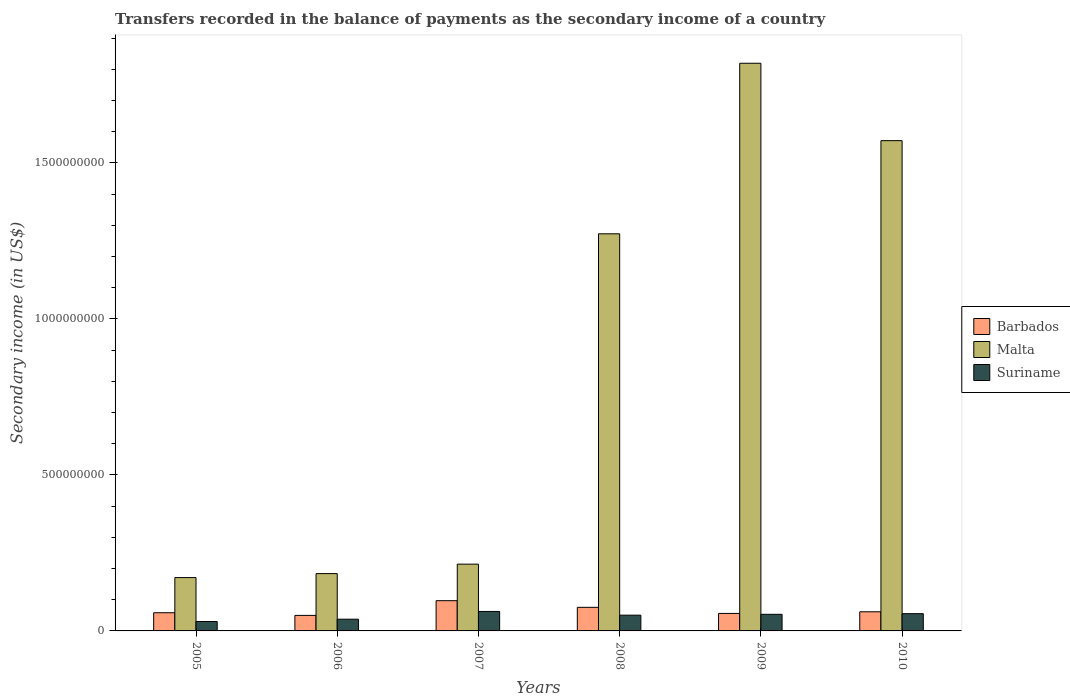How many different coloured bars are there?
Give a very brief answer. 3. How many groups of bars are there?
Your response must be concise. 6. Are the number of bars per tick equal to the number of legend labels?
Make the answer very short. Yes. How many bars are there on the 5th tick from the right?
Your answer should be compact. 3. What is the label of the 2nd group of bars from the left?
Keep it short and to the point. 2006. In how many cases, is the number of bars for a given year not equal to the number of legend labels?
Provide a succinct answer. 0. What is the secondary income of in Barbados in 2005?
Your response must be concise. 5.83e+07. Across all years, what is the maximum secondary income of in Suriname?
Provide a succinct answer. 6.24e+07. Across all years, what is the minimum secondary income of in Malta?
Your answer should be compact. 1.71e+08. What is the total secondary income of in Suriname in the graph?
Your answer should be very brief. 2.89e+08. What is the difference between the secondary income of in Malta in 2006 and that in 2008?
Give a very brief answer. -1.09e+09. What is the difference between the secondary income of in Barbados in 2008 and the secondary income of in Malta in 2009?
Your answer should be compact. -1.74e+09. What is the average secondary income of in Malta per year?
Your response must be concise. 8.72e+08. In the year 2010, what is the difference between the secondary income of in Suriname and secondary income of in Malta?
Ensure brevity in your answer.  -1.52e+09. What is the ratio of the secondary income of in Barbados in 2008 to that in 2010?
Make the answer very short. 1.23. Is the secondary income of in Barbados in 2005 less than that in 2007?
Give a very brief answer. Yes. Is the difference between the secondary income of in Suriname in 2007 and 2008 greater than the difference between the secondary income of in Malta in 2007 and 2008?
Your answer should be compact. Yes. What is the difference between the highest and the second highest secondary income of in Barbados?
Offer a very short reply. 2.13e+07. What is the difference between the highest and the lowest secondary income of in Malta?
Offer a terse response. 1.65e+09. What does the 3rd bar from the left in 2007 represents?
Your response must be concise. Suriname. What does the 2nd bar from the right in 2009 represents?
Make the answer very short. Malta. Is it the case that in every year, the sum of the secondary income of in Barbados and secondary income of in Suriname is greater than the secondary income of in Malta?
Keep it short and to the point. No. How many bars are there?
Your response must be concise. 18. How many years are there in the graph?
Your answer should be compact. 6. What is the difference between two consecutive major ticks on the Y-axis?
Provide a short and direct response. 5.00e+08. How are the legend labels stacked?
Offer a very short reply. Vertical. What is the title of the graph?
Your response must be concise. Transfers recorded in the balance of payments as the secondary income of a country. What is the label or title of the Y-axis?
Offer a very short reply. Secondary income (in US$). What is the Secondary income (in US$) in Barbados in 2005?
Offer a very short reply. 5.83e+07. What is the Secondary income (in US$) of Malta in 2005?
Your response must be concise. 1.71e+08. What is the Secondary income (in US$) in Suriname in 2005?
Keep it short and to the point. 3.02e+07. What is the Secondary income (in US$) in Barbados in 2006?
Make the answer very short. 4.97e+07. What is the Secondary income (in US$) in Malta in 2006?
Offer a terse response. 1.84e+08. What is the Secondary income (in US$) in Suriname in 2006?
Your answer should be compact. 3.76e+07. What is the Secondary income (in US$) in Barbados in 2007?
Keep it short and to the point. 9.69e+07. What is the Secondary income (in US$) in Malta in 2007?
Offer a terse response. 2.14e+08. What is the Secondary income (in US$) of Suriname in 2007?
Provide a succinct answer. 6.24e+07. What is the Secondary income (in US$) of Barbados in 2008?
Offer a terse response. 7.56e+07. What is the Secondary income (in US$) of Malta in 2008?
Provide a succinct answer. 1.27e+09. What is the Secondary income (in US$) in Suriname in 2008?
Ensure brevity in your answer.  5.05e+07. What is the Secondary income (in US$) of Barbados in 2009?
Ensure brevity in your answer.  5.61e+07. What is the Secondary income (in US$) in Malta in 2009?
Keep it short and to the point. 1.82e+09. What is the Secondary income (in US$) in Suriname in 2009?
Give a very brief answer. 5.32e+07. What is the Secondary income (in US$) in Barbados in 2010?
Offer a very short reply. 6.13e+07. What is the Secondary income (in US$) of Malta in 2010?
Your answer should be compact. 1.57e+09. What is the Secondary income (in US$) of Suriname in 2010?
Keep it short and to the point. 5.53e+07. Across all years, what is the maximum Secondary income (in US$) of Barbados?
Your response must be concise. 9.69e+07. Across all years, what is the maximum Secondary income (in US$) of Malta?
Make the answer very short. 1.82e+09. Across all years, what is the maximum Secondary income (in US$) of Suriname?
Make the answer very short. 6.24e+07. Across all years, what is the minimum Secondary income (in US$) in Barbados?
Provide a short and direct response. 4.97e+07. Across all years, what is the minimum Secondary income (in US$) in Malta?
Offer a very short reply. 1.71e+08. Across all years, what is the minimum Secondary income (in US$) of Suriname?
Your response must be concise. 3.02e+07. What is the total Secondary income (in US$) in Barbados in the graph?
Give a very brief answer. 3.98e+08. What is the total Secondary income (in US$) in Malta in the graph?
Keep it short and to the point. 5.23e+09. What is the total Secondary income (in US$) in Suriname in the graph?
Ensure brevity in your answer.  2.89e+08. What is the difference between the Secondary income (in US$) of Barbados in 2005 and that in 2006?
Provide a short and direct response. 8.51e+06. What is the difference between the Secondary income (in US$) of Malta in 2005 and that in 2006?
Keep it short and to the point. -1.27e+07. What is the difference between the Secondary income (in US$) of Suriname in 2005 and that in 2006?
Ensure brevity in your answer.  -7.40e+06. What is the difference between the Secondary income (in US$) in Barbados in 2005 and that in 2007?
Ensure brevity in your answer.  -3.86e+07. What is the difference between the Secondary income (in US$) in Malta in 2005 and that in 2007?
Your response must be concise. -4.30e+07. What is the difference between the Secondary income (in US$) in Suriname in 2005 and that in 2007?
Your answer should be compact. -3.22e+07. What is the difference between the Secondary income (in US$) in Barbados in 2005 and that in 2008?
Keep it short and to the point. -1.73e+07. What is the difference between the Secondary income (in US$) in Malta in 2005 and that in 2008?
Make the answer very short. -1.10e+09. What is the difference between the Secondary income (in US$) of Suriname in 2005 and that in 2008?
Your response must be concise. -2.03e+07. What is the difference between the Secondary income (in US$) in Barbados in 2005 and that in 2009?
Provide a succinct answer. 2.20e+06. What is the difference between the Secondary income (in US$) in Malta in 2005 and that in 2009?
Give a very brief answer. -1.65e+09. What is the difference between the Secondary income (in US$) of Suriname in 2005 and that in 2009?
Offer a terse response. -2.30e+07. What is the difference between the Secondary income (in US$) in Barbados in 2005 and that in 2010?
Keep it short and to the point. -3.06e+06. What is the difference between the Secondary income (in US$) in Malta in 2005 and that in 2010?
Make the answer very short. -1.40e+09. What is the difference between the Secondary income (in US$) of Suriname in 2005 and that in 2010?
Keep it short and to the point. -2.51e+07. What is the difference between the Secondary income (in US$) in Barbados in 2006 and that in 2007?
Give a very brief answer. -4.71e+07. What is the difference between the Secondary income (in US$) in Malta in 2006 and that in 2007?
Provide a succinct answer. -3.03e+07. What is the difference between the Secondary income (in US$) in Suriname in 2006 and that in 2007?
Offer a terse response. -2.48e+07. What is the difference between the Secondary income (in US$) in Barbados in 2006 and that in 2008?
Make the answer very short. -2.58e+07. What is the difference between the Secondary income (in US$) of Malta in 2006 and that in 2008?
Your answer should be very brief. -1.09e+09. What is the difference between the Secondary income (in US$) of Suriname in 2006 and that in 2008?
Your answer should be very brief. -1.29e+07. What is the difference between the Secondary income (in US$) in Barbados in 2006 and that in 2009?
Make the answer very short. -6.32e+06. What is the difference between the Secondary income (in US$) in Malta in 2006 and that in 2009?
Your response must be concise. -1.64e+09. What is the difference between the Secondary income (in US$) of Suriname in 2006 and that in 2009?
Provide a succinct answer. -1.56e+07. What is the difference between the Secondary income (in US$) of Barbados in 2006 and that in 2010?
Your answer should be very brief. -1.16e+07. What is the difference between the Secondary income (in US$) of Malta in 2006 and that in 2010?
Provide a short and direct response. -1.39e+09. What is the difference between the Secondary income (in US$) in Suriname in 2006 and that in 2010?
Offer a terse response. -1.77e+07. What is the difference between the Secondary income (in US$) of Barbados in 2007 and that in 2008?
Your response must be concise. 2.13e+07. What is the difference between the Secondary income (in US$) of Malta in 2007 and that in 2008?
Offer a terse response. -1.06e+09. What is the difference between the Secondary income (in US$) of Suriname in 2007 and that in 2008?
Ensure brevity in your answer.  1.19e+07. What is the difference between the Secondary income (in US$) in Barbados in 2007 and that in 2009?
Offer a very short reply. 4.08e+07. What is the difference between the Secondary income (in US$) in Malta in 2007 and that in 2009?
Give a very brief answer. -1.61e+09. What is the difference between the Secondary income (in US$) in Suriname in 2007 and that in 2009?
Give a very brief answer. 9.20e+06. What is the difference between the Secondary income (in US$) of Barbados in 2007 and that in 2010?
Ensure brevity in your answer.  3.56e+07. What is the difference between the Secondary income (in US$) in Malta in 2007 and that in 2010?
Your answer should be very brief. -1.36e+09. What is the difference between the Secondary income (in US$) in Suriname in 2007 and that in 2010?
Offer a very short reply. 7.10e+06. What is the difference between the Secondary income (in US$) in Barbados in 2008 and that in 2009?
Offer a very short reply. 1.95e+07. What is the difference between the Secondary income (in US$) of Malta in 2008 and that in 2009?
Make the answer very short. -5.47e+08. What is the difference between the Secondary income (in US$) of Suriname in 2008 and that in 2009?
Keep it short and to the point. -2.70e+06. What is the difference between the Secondary income (in US$) in Barbados in 2008 and that in 2010?
Offer a very short reply. 1.43e+07. What is the difference between the Secondary income (in US$) of Malta in 2008 and that in 2010?
Your response must be concise. -2.99e+08. What is the difference between the Secondary income (in US$) of Suriname in 2008 and that in 2010?
Provide a short and direct response. -4.80e+06. What is the difference between the Secondary income (in US$) in Barbados in 2009 and that in 2010?
Your answer should be compact. -5.26e+06. What is the difference between the Secondary income (in US$) of Malta in 2009 and that in 2010?
Your response must be concise. 2.48e+08. What is the difference between the Secondary income (in US$) in Suriname in 2009 and that in 2010?
Provide a succinct answer. -2.10e+06. What is the difference between the Secondary income (in US$) in Barbados in 2005 and the Secondary income (in US$) in Malta in 2006?
Give a very brief answer. -1.25e+08. What is the difference between the Secondary income (in US$) in Barbados in 2005 and the Secondary income (in US$) in Suriname in 2006?
Give a very brief answer. 2.07e+07. What is the difference between the Secondary income (in US$) of Malta in 2005 and the Secondary income (in US$) of Suriname in 2006?
Give a very brief answer. 1.33e+08. What is the difference between the Secondary income (in US$) of Barbados in 2005 and the Secondary income (in US$) of Malta in 2007?
Make the answer very short. -1.56e+08. What is the difference between the Secondary income (in US$) of Barbados in 2005 and the Secondary income (in US$) of Suriname in 2007?
Provide a short and direct response. -4.14e+06. What is the difference between the Secondary income (in US$) of Malta in 2005 and the Secondary income (in US$) of Suriname in 2007?
Offer a very short reply. 1.09e+08. What is the difference between the Secondary income (in US$) in Barbados in 2005 and the Secondary income (in US$) in Malta in 2008?
Make the answer very short. -1.21e+09. What is the difference between the Secondary income (in US$) of Barbados in 2005 and the Secondary income (in US$) of Suriname in 2008?
Make the answer very short. 7.76e+06. What is the difference between the Secondary income (in US$) in Malta in 2005 and the Secondary income (in US$) in Suriname in 2008?
Give a very brief answer. 1.20e+08. What is the difference between the Secondary income (in US$) in Barbados in 2005 and the Secondary income (in US$) in Malta in 2009?
Offer a very short reply. -1.76e+09. What is the difference between the Secondary income (in US$) in Barbados in 2005 and the Secondary income (in US$) in Suriname in 2009?
Your response must be concise. 5.06e+06. What is the difference between the Secondary income (in US$) in Malta in 2005 and the Secondary income (in US$) in Suriname in 2009?
Give a very brief answer. 1.18e+08. What is the difference between the Secondary income (in US$) in Barbados in 2005 and the Secondary income (in US$) in Malta in 2010?
Provide a succinct answer. -1.51e+09. What is the difference between the Secondary income (in US$) of Barbados in 2005 and the Secondary income (in US$) of Suriname in 2010?
Your response must be concise. 2.96e+06. What is the difference between the Secondary income (in US$) in Malta in 2005 and the Secondary income (in US$) in Suriname in 2010?
Your response must be concise. 1.16e+08. What is the difference between the Secondary income (in US$) in Barbados in 2006 and the Secondary income (in US$) in Malta in 2007?
Provide a succinct answer. -1.64e+08. What is the difference between the Secondary income (in US$) of Barbados in 2006 and the Secondary income (in US$) of Suriname in 2007?
Your answer should be compact. -1.27e+07. What is the difference between the Secondary income (in US$) in Malta in 2006 and the Secondary income (in US$) in Suriname in 2007?
Make the answer very short. 1.21e+08. What is the difference between the Secondary income (in US$) of Barbados in 2006 and the Secondary income (in US$) of Malta in 2008?
Ensure brevity in your answer.  -1.22e+09. What is the difference between the Secondary income (in US$) of Barbados in 2006 and the Secondary income (in US$) of Suriname in 2008?
Keep it short and to the point. -7.51e+05. What is the difference between the Secondary income (in US$) in Malta in 2006 and the Secondary income (in US$) in Suriname in 2008?
Offer a terse response. 1.33e+08. What is the difference between the Secondary income (in US$) of Barbados in 2006 and the Secondary income (in US$) of Malta in 2009?
Your response must be concise. -1.77e+09. What is the difference between the Secondary income (in US$) of Barbados in 2006 and the Secondary income (in US$) of Suriname in 2009?
Provide a short and direct response. -3.45e+06. What is the difference between the Secondary income (in US$) in Malta in 2006 and the Secondary income (in US$) in Suriname in 2009?
Offer a very short reply. 1.31e+08. What is the difference between the Secondary income (in US$) of Barbados in 2006 and the Secondary income (in US$) of Malta in 2010?
Provide a short and direct response. -1.52e+09. What is the difference between the Secondary income (in US$) of Barbados in 2006 and the Secondary income (in US$) of Suriname in 2010?
Keep it short and to the point. -5.55e+06. What is the difference between the Secondary income (in US$) of Malta in 2006 and the Secondary income (in US$) of Suriname in 2010?
Offer a terse response. 1.28e+08. What is the difference between the Secondary income (in US$) in Barbados in 2007 and the Secondary income (in US$) in Malta in 2008?
Make the answer very short. -1.18e+09. What is the difference between the Secondary income (in US$) in Barbados in 2007 and the Secondary income (in US$) in Suriname in 2008?
Your answer should be very brief. 4.64e+07. What is the difference between the Secondary income (in US$) in Malta in 2007 and the Secondary income (in US$) in Suriname in 2008?
Provide a short and direct response. 1.64e+08. What is the difference between the Secondary income (in US$) in Barbados in 2007 and the Secondary income (in US$) in Malta in 2009?
Your answer should be compact. -1.72e+09. What is the difference between the Secondary income (in US$) of Barbados in 2007 and the Secondary income (in US$) of Suriname in 2009?
Your answer should be very brief. 4.37e+07. What is the difference between the Secondary income (in US$) in Malta in 2007 and the Secondary income (in US$) in Suriname in 2009?
Make the answer very short. 1.61e+08. What is the difference between the Secondary income (in US$) of Barbados in 2007 and the Secondary income (in US$) of Malta in 2010?
Your answer should be compact. -1.47e+09. What is the difference between the Secondary income (in US$) in Barbados in 2007 and the Secondary income (in US$) in Suriname in 2010?
Your response must be concise. 4.16e+07. What is the difference between the Secondary income (in US$) of Malta in 2007 and the Secondary income (in US$) of Suriname in 2010?
Give a very brief answer. 1.59e+08. What is the difference between the Secondary income (in US$) of Barbados in 2008 and the Secondary income (in US$) of Malta in 2009?
Your answer should be very brief. -1.74e+09. What is the difference between the Secondary income (in US$) of Barbados in 2008 and the Secondary income (in US$) of Suriname in 2009?
Provide a succinct answer. 2.24e+07. What is the difference between the Secondary income (in US$) in Malta in 2008 and the Secondary income (in US$) in Suriname in 2009?
Keep it short and to the point. 1.22e+09. What is the difference between the Secondary income (in US$) of Barbados in 2008 and the Secondary income (in US$) of Malta in 2010?
Offer a terse response. -1.50e+09. What is the difference between the Secondary income (in US$) in Barbados in 2008 and the Secondary income (in US$) in Suriname in 2010?
Your answer should be compact. 2.03e+07. What is the difference between the Secondary income (in US$) in Malta in 2008 and the Secondary income (in US$) in Suriname in 2010?
Keep it short and to the point. 1.22e+09. What is the difference between the Secondary income (in US$) in Barbados in 2009 and the Secondary income (in US$) in Malta in 2010?
Offer a terse response. -1.52e+09. What is the difference between the Secondary income (in US$) of Barbados in 2009 and the Secondary income (in US$) of Suriname in 2010?
Offer a very short reply. 7.66e+05. What is the difference between the Secondary income (in US$) in Malta in 2009 and the Secondary income (in US$) in Suriname in 2010?
Offer a very short reply. 1.76e+09. What is the average Secondary income (in US$) in Barbados per year?
Provide a succinct answer. 6.63e+07. What is the average Secondary income (in US$) of Malta per year?
Give a very brief answer. 8.72e+08. What is the average Secondary income (in US$) in Suriname per year?
Offer a very short reply. 4.82e+07. In the year 2005, what is the difference between the Secondary income (in US$) in Barbados and Secondary income (in US$) in Malta?
Make the answer very short. -1.13e+08. In the year 2005, what is the difference between the Secondary income (in US$) in Barbados and Secondary income (in US$) in Suriname?
Your answer should be very brief. 2.81e+07. In the year 2005, what is the difference between the Secondary income (in US$) in Malta and Secondary income (in US$) in Suriname?
Offer a very short reply. 1.41e+08. In the year 2006, what is the difference between the Secondary income (in US$) in Barbados and Secondary income (in US$) in Malta?
Provide a short and direct response. -1.34e+08. In the year 2006, what is the difference between the Secondary income (in US$) in Barbados and Secondary income (in US$) in Suriname?
Offer a terse response. 1.21e+07. In the year 2006, what is the difference between the Secondary income (in US$) in Malta and Secondary income (in US$) in Suriname?
Provide a short and direct response. 1.46e+08. In the year 2007, what is the difference between the Secondary income (in US$) in Barbados and Secondary income (in US$) in Malta?
Provide a succinct answer. -1.17e+08. In the year 2007, what is the difference between the Secondary income (in US$) of Barbados and Secondary income (in US$) of Suriname?
Make the answer very short. 3.45e+07. In the year 2007, what is the difference between the Secondary income (in US$) of Malta and Secondary income (in US$) of Suriname?
Your answer should be compact. 1.52e+08. In the year 2008, what is the difference between the Secondary income (in US$) of Barbados and Secondary income (in US$) of Malta?
Give a very brief answer. -1.20e+09. In the year 2008, what is the difference between the Secondary income (in US$) in Barbados and Secondary income (in US$) in Suriname?
Keep it short and to the point. 2.51e+07. In the year 2008, what is the difference between the Secondary income (in US$) of Malta and Secondary income (in US$) of Suriname?
Offer a terse response. 1.22e+09. In the year 2009, what is the difference between the Secondary income (in US$) of Barbados and Secondary income (in US$) of Malta?
Make the answer very short. -1.76e+09. In the year 2009, what is the difference between the Secondary income (in US$) in Barbados and Secondary income (in US$) in Suriname?
Make the answer very short. 2.87e+06. In the year 2009, what is the difference between the Secondary income (in US$) of Malta and Secondary income (in US$) of Suriname?
Your answer should be very brief. 1.77e+09. In the year 2010, what is the difference between the Secondary income (in US$) in Barbados and Secondary income (in US$) in Malta?
Your answer should be compact. -1.51e+09. In the year 2010, what is the difference between the Secondary income (in US$) in Barbados and Secondary income (in US$) in Suriname?
Offer a very short reply. 6.03e+06. In the year 2010, what is the difference between the Secondary income (in US$) of Malta and Secondary income (in US$) of Suriname?
Give a very brief answer. 1.52e+09. What is the ratio of the Secondary income (in US$) of Barbados in 2005 to that in 2006?
Provide a succinct answer. 1.17. What is the ratio of the Secondary income (in US$) of Malta in 2005 to that in 2006?
Your answer should be very brief. 0.93. What is the ratio of the Secondary income (in US$) in Suriname in 2005 to that in 2006?
Provide a short and direct response. 0.8. What is the ratio of the Secondary income (in US$) of Barbados in 2005 to that in 2007?
Your answer should be compact. 0.6. What is the ratio of the Secondary income (in US$) of Malta in 2005 to that in 2007?
Keep it short and to the point. 0.8. What is the ratio of the Secondary income (in US$) of Suriname in 2005 to that in 2007?
Your response must be concise. 0.48. What is the ratio of the Secondary income (in US$) in Barbados in 2005 to that in 2008?
Your response must be concise. 0.77. What is the ratio of the Secondary income (in US$) of Malta in 2005 to that in 2008?
Your answer should be very brief. 0.13. What is the ratio of the Secondary income (in US$) of Suriname in 2005 to that in 2008?
Your answer should be compact. 0.6. What is the ratio of the Secondary income (in US$) in Barbados in 2005 to that in 2009?
Ensure brevity in your answer.  1.04. What is the ratio of the Secondary income (in US$) in Malta in 2005 to that in 2009?
Keep it short and to the point. 0.09. What is the ratio of the Secondary income (in US$) of Suriname in 2005 to that in 2009?
Make the answer very short. 0.57. What is the ratio of the Secondary income (in US$) of Barbados in 2005 to that in 2010?
Offer a very short reply. 0.95. What is the ratio of the Secondary income (in US$) in Malta in 2005 to that in 2010?
Provide a succinct answer. 0.11. What is the ratio of the Secondary income (in US$) in Suriname in 2005 to that in 2010?
Offer a terse response. 0.55. What is the ratio of the Secondary income (in US$) in Barbados in 2006 to that in 2007?
Your response must be concise. 0.51. What is the ratio of the Secondary income (in US$) in Malta in 2006 to that in 2007?
Ensure brevity in your answer.  0.86. What is the ratio of the Secondary income (in US$) of Suriname in 2006 to that in 2007?
Give a very brief answer. 0.6. What is the ratio of the Secondary income (in US$) of Barbados in 2006 to that in 2008?
Your answer should be compact. 0.66. What is the ratio of the Secondary income (in US$) in Malta in 2006 to that in 2008?
Your answer should be compact. 0.14. What is the ratio of the Secondary income (in US$) of Suriname in 2006 to that in 2008?
Offer a terse response. 0.74. What is the ratio of the Secondary income (in US$) in Barbados in 2006 to that in 2009?
Your answer should be very brief. 0.89. What is the ratio of the Secondary income (in US$) in Malta in 2006 to that in 2009?
Give a very brief answer. 0.1. What is the ratio of the Secondary income (in US$) in Suriname in 2006 to that in 2009?
Provide a short and direct response. 0.71. What is the ratio of the Secondary income (in US$) in Barbados in 2006 to that in 2010?
Give a very brief answer. 0.81. What is the ratio of the Secondary income (in US$) in Malta in 2006 to that in 2010?
Provide a succinct answer. 0.12. What is the ratio of the Secondary income (in US$) in Suriname in 2006 to that in 2010?
Ensure brevity in your answer.  0.68. What is the ratio of the Secondary income (in US$) in Barbados in 2007 to that in 2008?
Provide a short and direct response. 1.28. What is the ratio of the Secondary income (in US$) in Malta in 2007 to that in 2008?
Offer a terse response. 0.17. What is the ratio of the Secondary income (in US$) of Suriname in 2007 to that in 2008?
Provide a short and direct response. 1.24. What is the ratio of the Secondary income (in US$) of Barbados in 2007 to that in 2009?
Your response must be concise. 1.73. What is the ratio of the Secondary income (in US$) of Malta in 2007 to that in 2009?
Make the answer very short. 0.12. What is the ratio of the Secondary income (in US$) of Suriname in 2007 to that in 2009?
Provide a succinct answer. 1.17. What is the ratio of the Secondary income (in US$) in Barbados in 2007 to that in 2010?
Ensure brevity in your answer.  1.58. What is the ratio of the Secondary income (in US$) in Malta in 2007 to that in 2010?
Offer a terse response. 0.14. What is the ratio of the Secondary income (in US$) in Suriname in 2007 to that in 2010?
Your response must be concise. 1.13. What is the ratio of the Secondary income (in US$) of Barbados in 2008 to that in 2009?
Give a very brief answer. 1.35. What is the ratio of the Secondary income (in US$) in Malta in 2008 to that in 2009?
Make the answer very short. 0.7. What is the ratio of the Secondary income (in US$) of Suriname in 2008 to that in 2009?
Your response must be concise. 0.95. What is the ratio of the Secondary income (in US$) of Barbados in 2008 to that in 2010?
Ensure brevity in your answer.  1.23. What is the ratio of the Secondary income (in US$) of Malta in 2008 to that in 2010?
Your response must be concise. 0.81. What is the ratio of the Secondary income (in US$) of Suriname in 2008 to that in 2010?
Offer a terse response. 0.91. What is the ratio of the Secondary income (in US$) of Barbados in 2009 to that in 2010?
Your answer should be compact. 0.91. What is the ratio of the Secondary income (in US$) of Malta in 2009 to that in 2010?
Keep it short and to the point. 1.16. What is the ratio of the Secondary income (in US$) of Suriname in 2009 to that in 2010?
Give a very brief answer. 0.96. What is the difference between the highest and the second highest Secondary income (in US$) in Barbados?
Offer a very short reply. 2.13e+07. What is the difference between the highest and the second highest Secondary income (in US$) of Malta?
Offer a terse response. 2.48e+08. What is the difference between the highest and the second highest Secondary income (in US$) of Suriname?
Your response must be concise. 7.10e+06. What is the difference between the highest and the lowest Secondary income (in US$) in Barbados?
Offer a very short reply. 4.71e+07. What is the difference between the highest and the lowest Secondary income (in US$) in Malta?
Your answer should be compact. 1.65e+09. What is the difference between the highest and the lowest Secondary income (in US$) of Suriname?
Ensure brevity in your answer.  3.22e+07. 